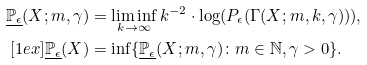<formula> <loc_0><loc_0><loc_500><loc_500>\underline { \mathbb { P } _ { \epsilon } } ( X ; m , \gamma ) & = \liminf _ { k \rightarrow \infty } k ^ { - 2 } \cdot \log ( P _ { \epsilon } ( \Gamma ( X ; m , k , \gamma ) ) ) , \\ [ 1 e x ] \underline { \mathbb { P } _ { \epsilon } } ( X ) & = \inf \{ \underline { \mathbb { P } _ { \epsilon } } ( X ; m , \gamma ) \colon m \in \mathbb { N } , \gamma > 0 \} .</formula> 